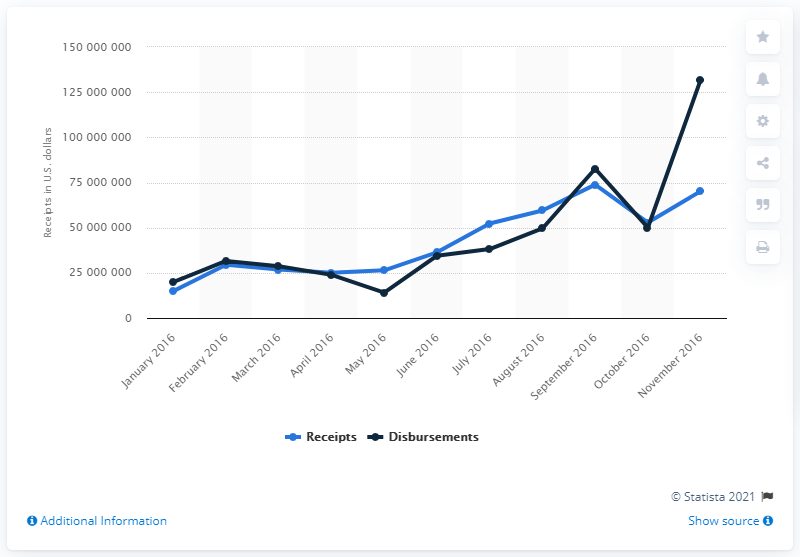Identify some key points in this picture. The amount of money received by Hillary Clinton's campaign for the 2016 U.S. presidential election was approximately 70189899.17 dollars. 